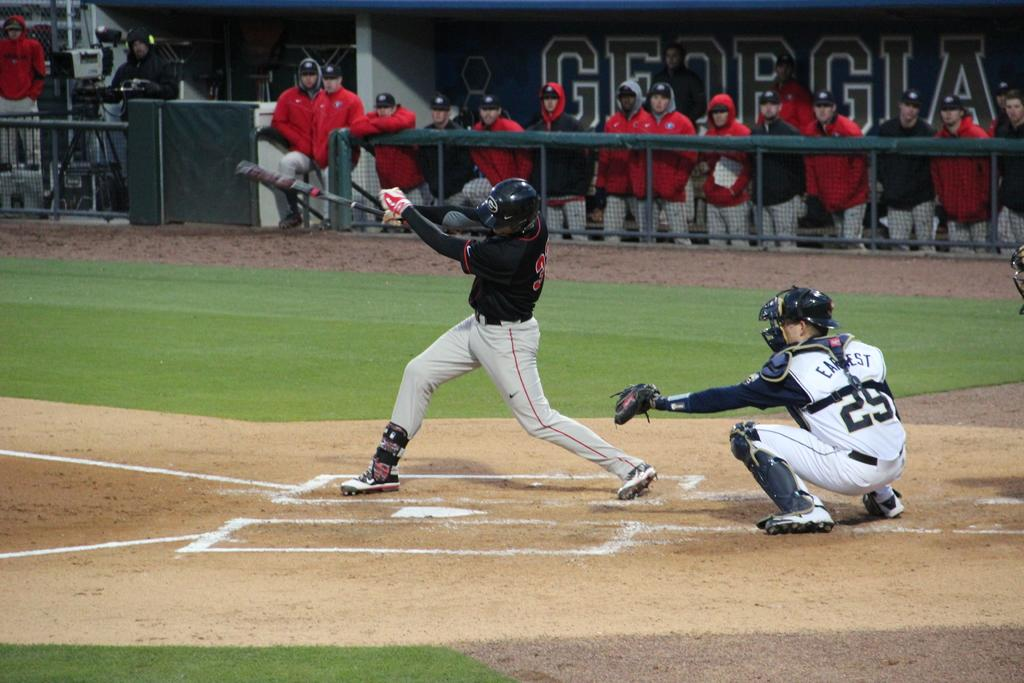Provide a one-sentence caption for the provided image. A baseball batter swings at a pitch at a Georgia game. 